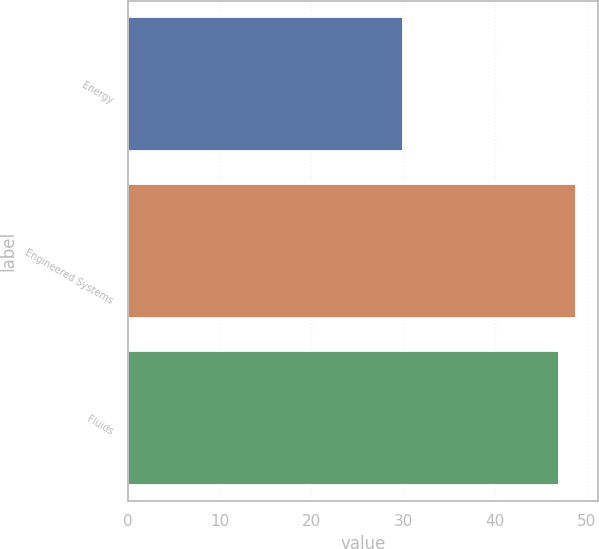Convert chart. <chart><loc_0><loc_0><loc_500><loc_500><bar_chart><fcel>Energy<fcel>Engineered Systems<fcel>Fluids<nl><fcel>30<fcel>48.8<fcel>47<nl></chart> 